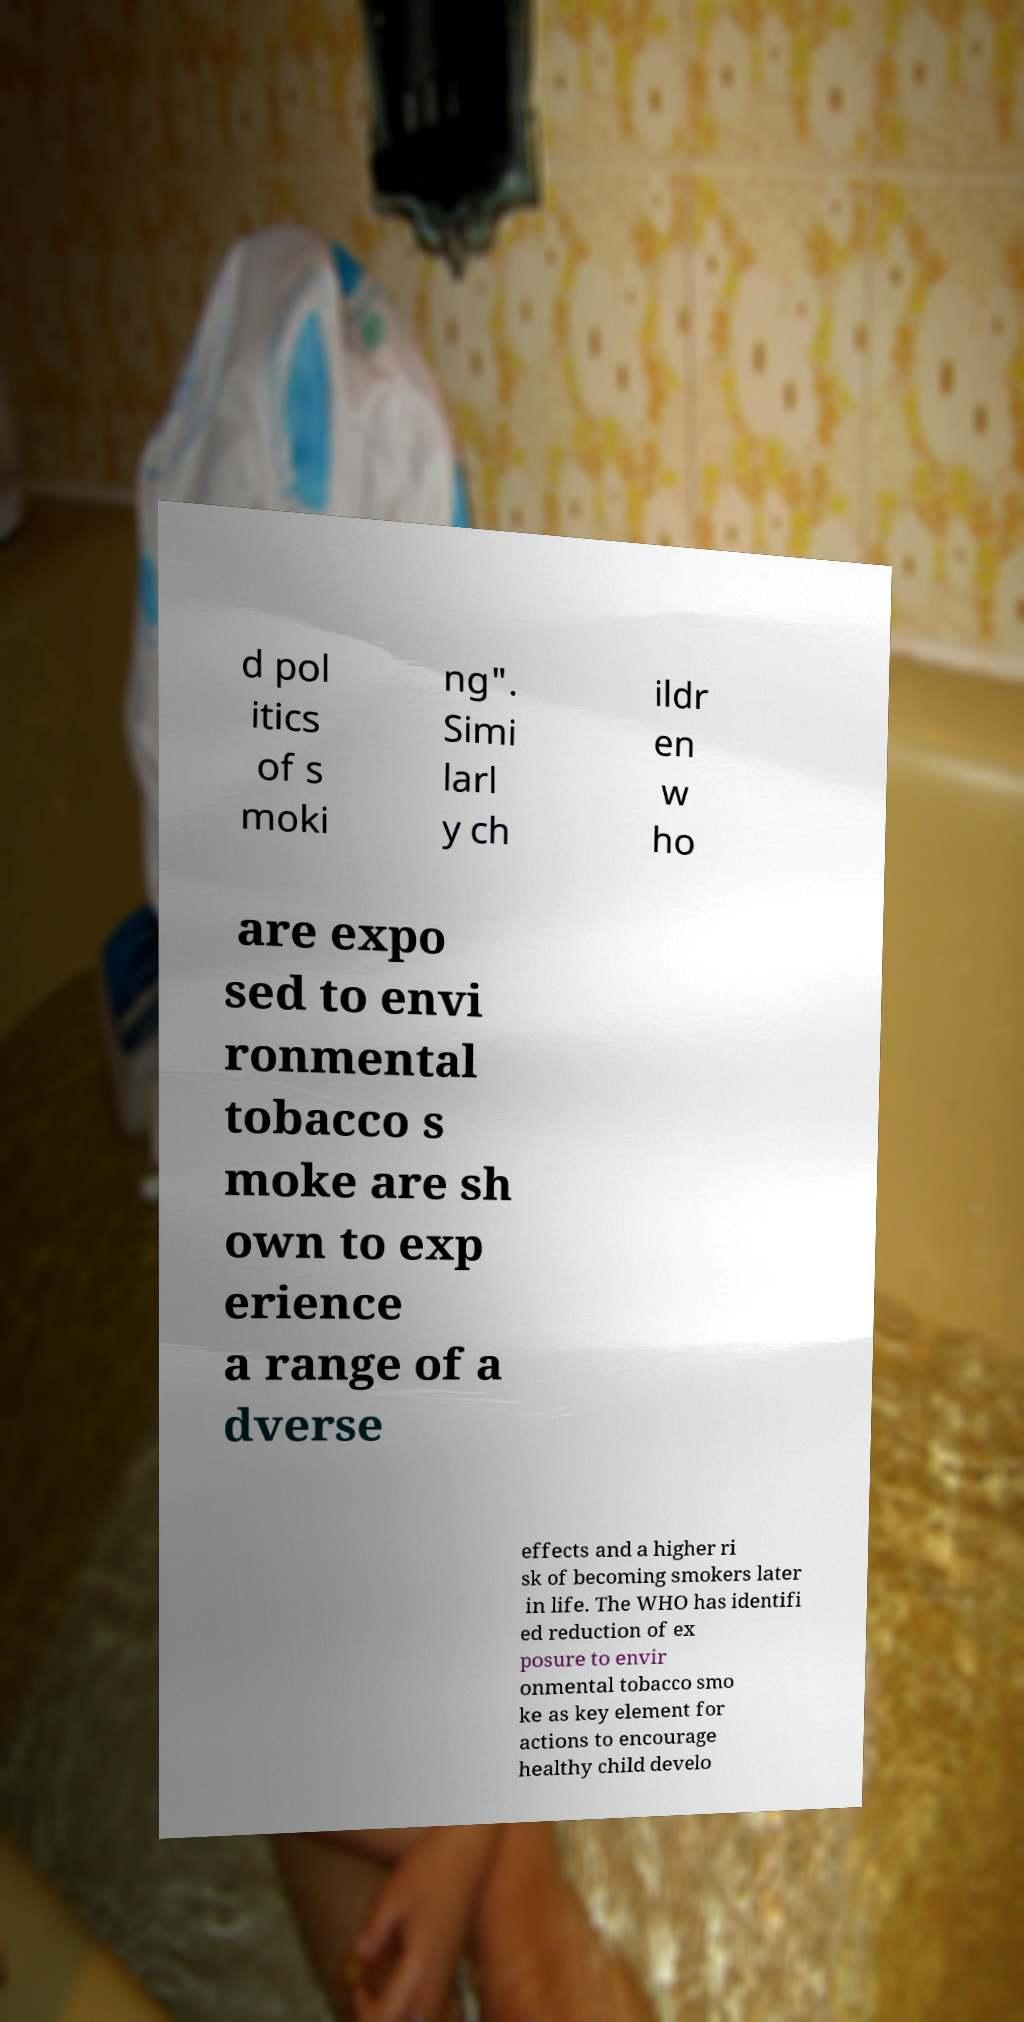Could you extract and type out the text from this image? d pol itics of s moki ng". Simi larl y ch ildr en w ho are expo sed to envi ronmental tobacco s moke are sh own to exp erience a range of a dverse effects and a higher ri sk of becoming smokers later in life. The WHO has identifi ed reduction of ex posure to envir onmental tobacco smo ke as key element for actions to encourage healthy child develo 